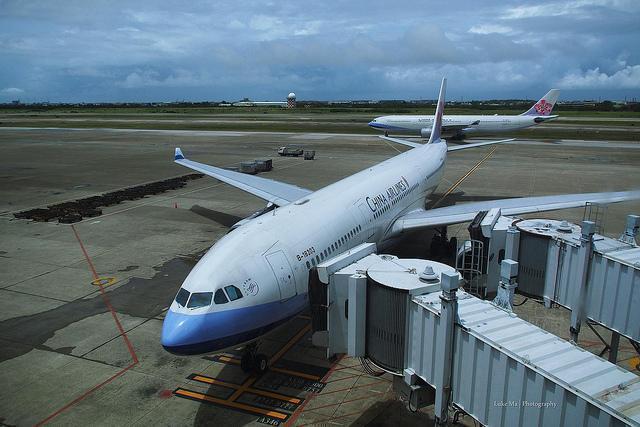What is the tunnel nearest the plane door called?
Select the correct answer and articulate reasoning with the following format: 'Answer: answer
Rationale: rationale.'
Options: Jet bridge, air tunnel, luggage tunnel, escape tunnel. Answer: jet bridge.
Rationale: It is for passengers to cross from their terminal gate to the plane without having to go downstairs or outdoors. 